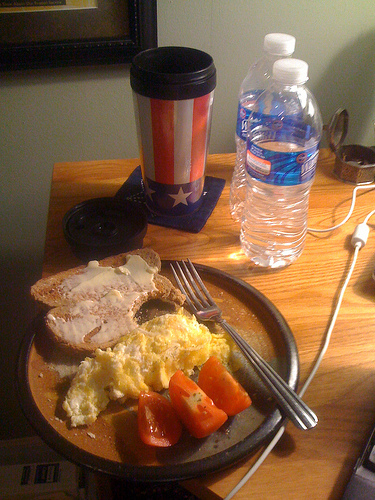<image>
Is there a bottle to the left of the bottle? No. The bottle is not to the left of the bottle. From this viewpoint, they have a different horizontal relationship. 